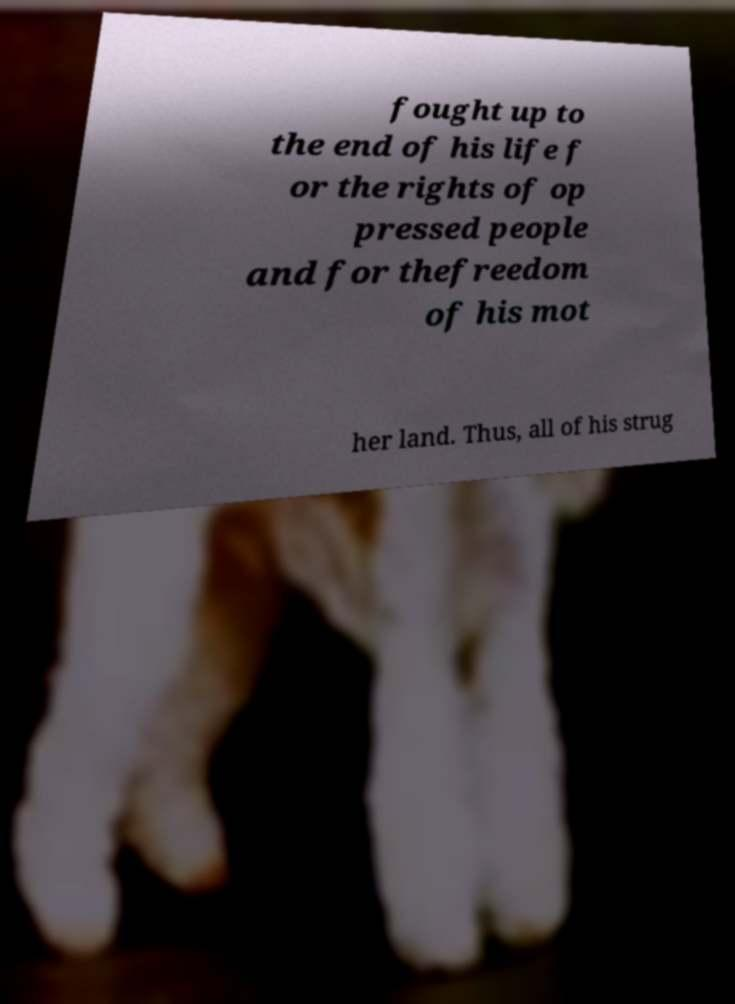For documentation purposes, I need the text within this image transcribed. Could you provide that? fought up to the end of his life f or the rights of op pressed people and for thefreedom of his mot her land. Thus, all of his strug 